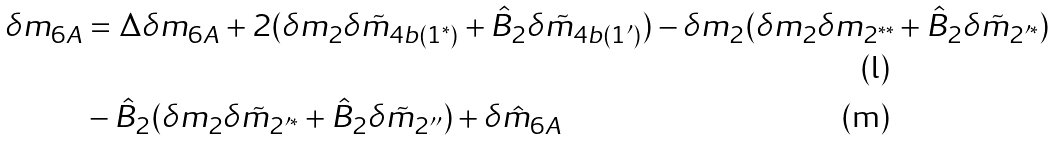<formula> <loc_0><loc_0><loc_500><loc_500>\delta m _ { 6 A } & = \Delta \delta m _ { 6 A } + 2 ( \delta m _ { 2 } \delta \tilde { m } _ { 4 b ( 1 ^ { \ast } ) } + \hat { B } _ { 2 } \delta \tilde { m } _ { 4 b ( 1 ^ { \prime } ) } ) - \delta m _ { 2 } ( \delta m _ { 2 } \delta m _ { 2 ^ { \ast \ast } } + \hat { B } _ { 2 } \delta \tilde { m } _ { 2 ^ { \prime \ast } } ) \\ & - \hat { B } _ { 2 } ( \delta m _ { 2 } \delta \tilde { m } _ { 2 ^ { \prime \ast } } + \hat { B } _ { 2 } \delta \tilde { m } _ { 2 ^ { \prime \prime } } ) + \delta \hat { m } _ { 6 A }</formula> 